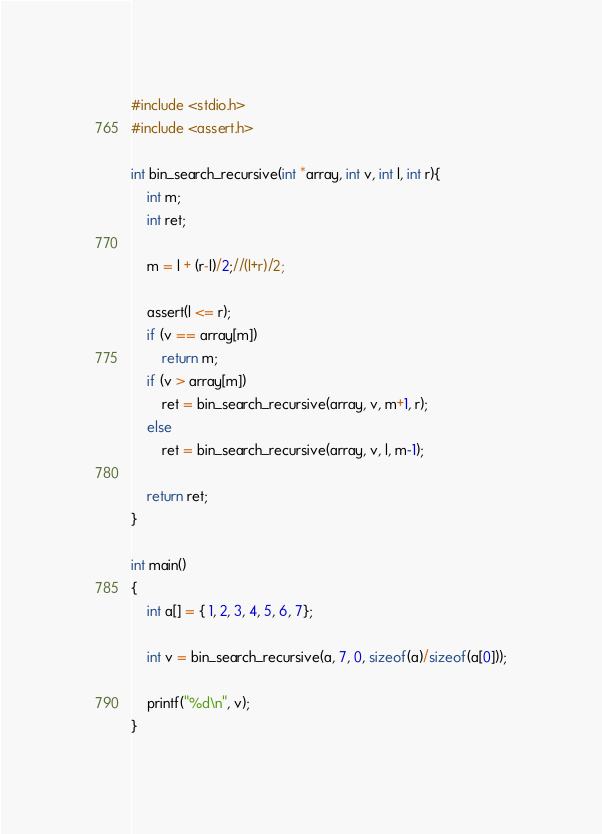<code> <loc_0><loc_0><loc_500><loc_500><_C_>#include <stdio.h>
#include <assert.h>

int bin_search_recursive(int *array, int v, int l, int r){
	int m;
	int ret;

	m = l + (r-l)/2;//(l+r)/2;

	assert(l <= r);
	if (v == array[m])
		return m;
	if (v > array[m])
		ret = bin_search_recursive(array, v, m+1, r);
	else
		ret = bin_search_recursive(array, v, l, m-1);

	return ret;
}

int main()
{
	int a[] = { 1, 2, 3, 4, 5, 6, 7};

	int v = bin_search_recursive(a, 7, 0, sizeof(a)/sizeof(a[0]));

	printf("%d\n", v);
}</code> 